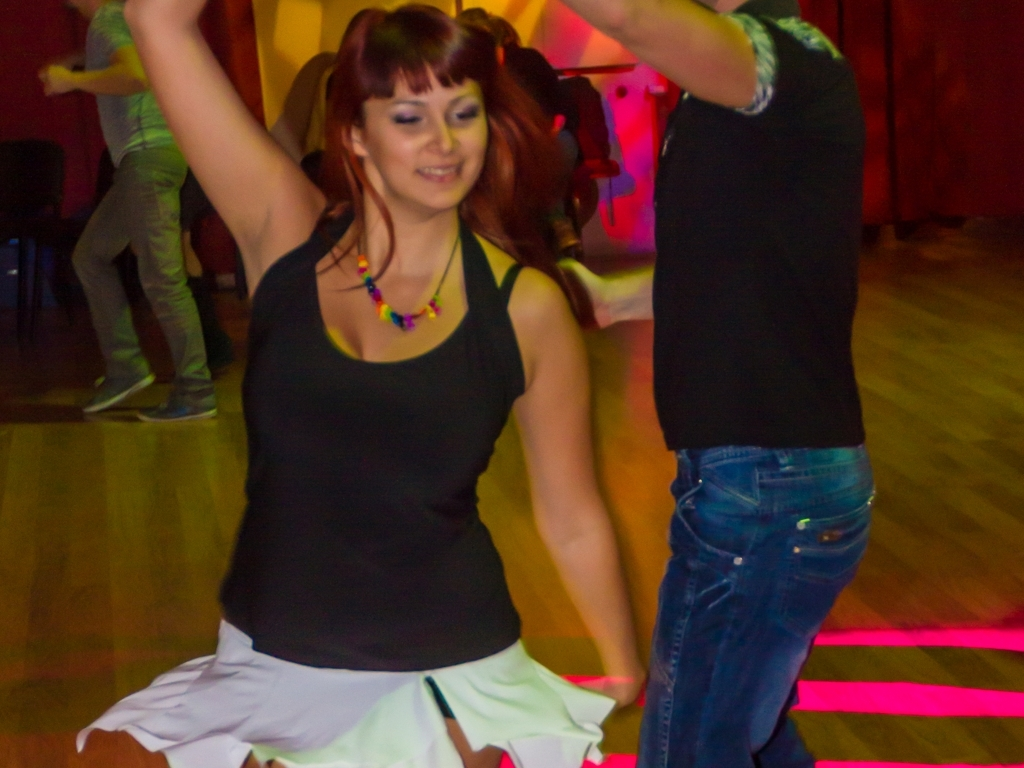Are there any quality issues with this image? Yes, there are quality issues with this image. The photo appears to be taken with low lighting, resulting in an underexposed image which makes it difficult to see finer details. Additionally, there is evident motion blur, particularly around the people's arms and legs, indicating that the shutter speed was not fast enough to freeze the movement of the dancers. Furthermore, the focus seems soft, suggesting that the camera's autofocus might have struggled in the dim lighting conditions. 